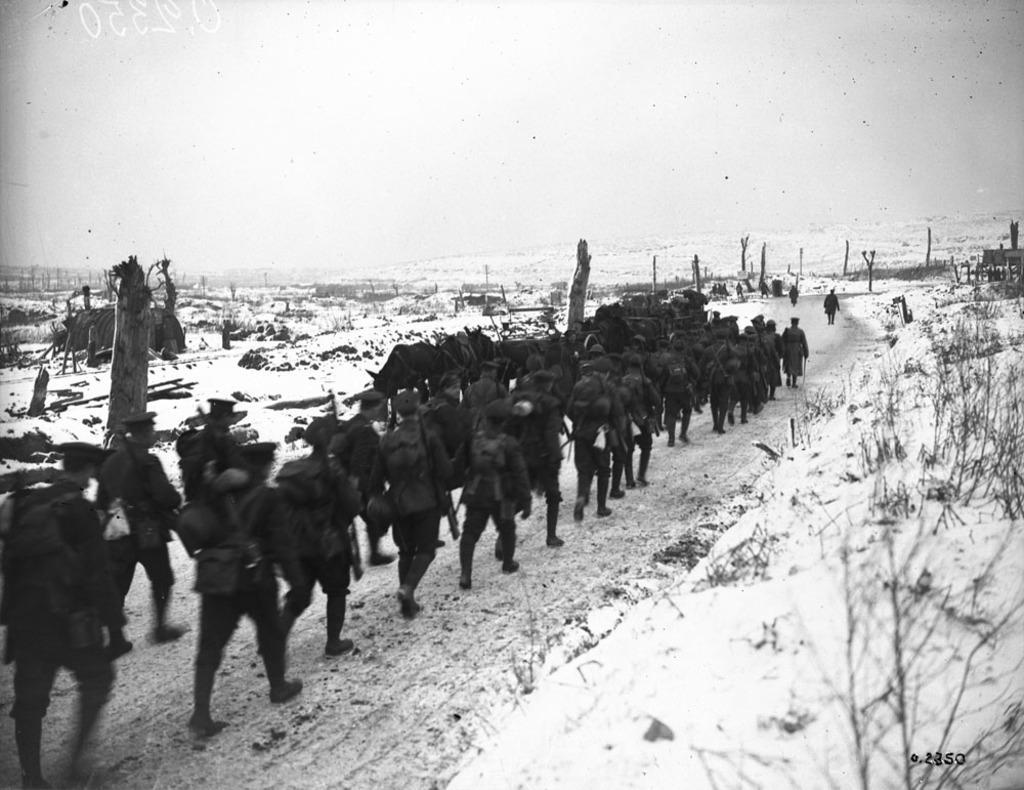How would you summarize this image in a sentence or two? In this image, I can see snow, grass, plants and a group of people are walking on the road. In the background, I can see poles, some objects and the sky. This image taken, maybe on the road. 